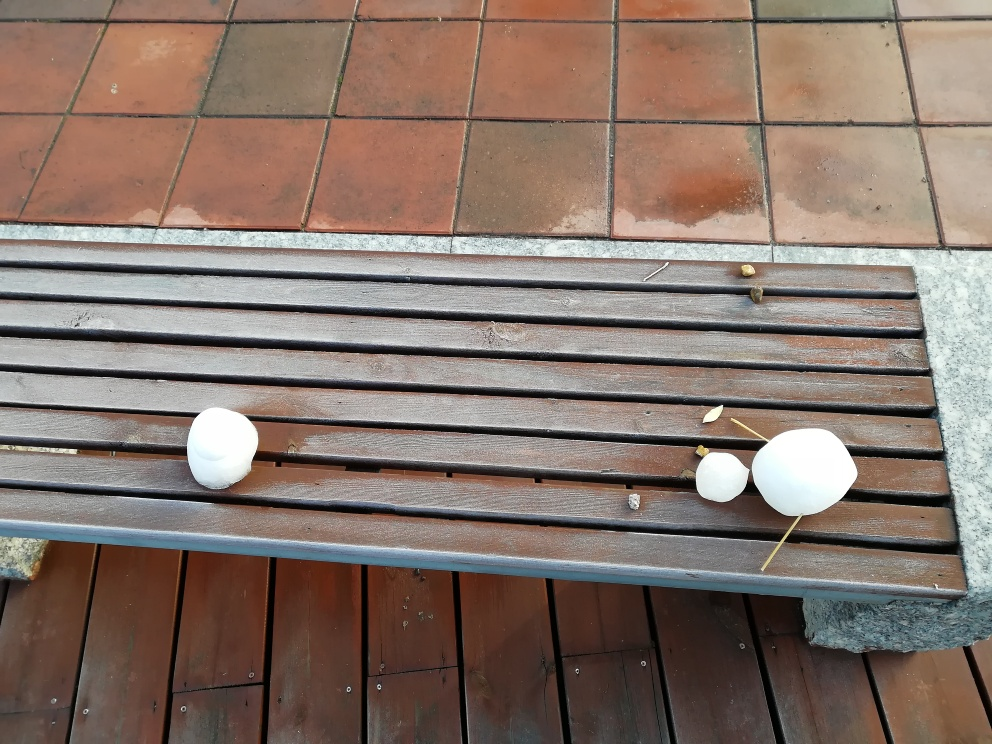How does the background contribute to the overall mood of the image? The background of terracotta tiles juxtaposed with the wooden bench adds a rustic and warm quality to the image. This setting could evoke feelings of outdoor relaxation or represent a domestic, familiar environment, contrasting with the unexpected arrangement of eggs, which adds a touch of whimsy. 